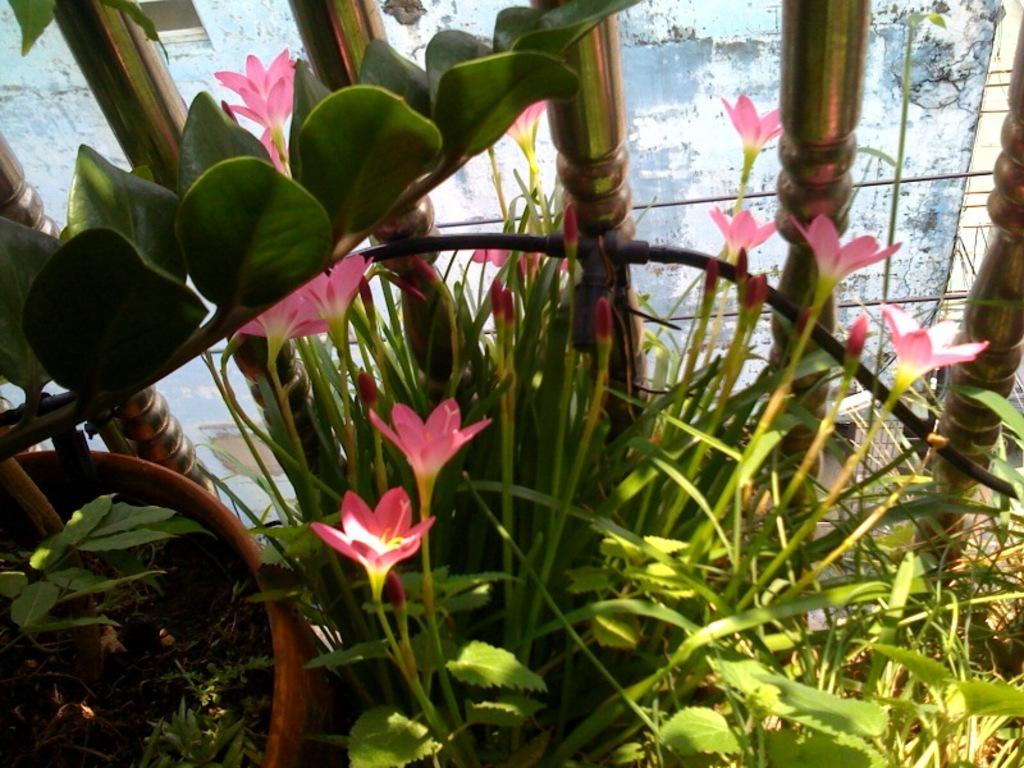What type of plants are in the image? There are plants in pots in the image. What stage of growth are the plants in? The plants have flowers and buds. What else can be seen in the image besides the plants? There are poles visible in the image. What is the background of the image? There is a wall in the image. What type of toy can be seen in the hands of the giants in the image? There are no giants or toys present in the image; it features plants in pots, poles, and a wall. 